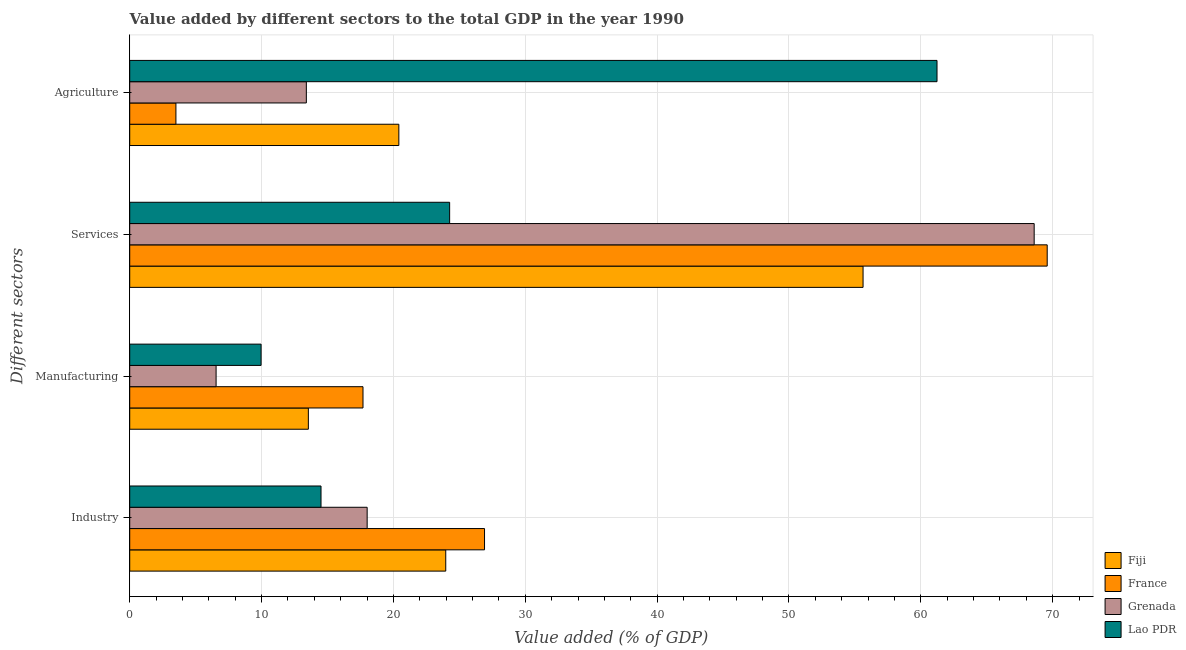Are the number of bars per tick equal to the number of legend labels?
Ensure brevity in your answer.  Yes. Are the number of bars on each tick of the Y-axis equal?
Provide a succinct answer. Yes. How many bars are there on the 3rd tick from the top?
Make the answer very short. 4. How many bars are there on the 3rd tick from the bottom?
Provide a succinct answer. 4. What is the label of the 3rd group of bars from the top?
Offer a very short reply. Manufacturing. What is the value added by industrial sector in Fiji?
Offer a terse response. 23.97. Across all countries, what is the maximum value added by industrial sector?
Keep it short and to the point. 26.91. Across all countries, what is the minimum value added by industrial sector?
Keep it short and to the point. 14.51. In which country was the value added by agricultural sector minimum?
Your answer should be compact. France. What is the total value added by industrial sector in the graph?
Give a very brief answer. 83.4. What is the difference between the value added by agricultural sector in Fiji and that in Grenada?
Your response must be concise. 7.02. What is the difference between the value added by industrial sector in France and the value added by agricultural sector in Lao PDR?
Your response must be concise. -34.32. What is the average value added by industrial sector per country?
Make the answer very short. 20.85. What is the difference between the value added by industrial sector and value added by services sector in Lao PDR?
Give a very brief answer. -9.76. In how many countries, is the value added by agricultural sector greater than 4 %?
Offer a very short reply. 3. What is the ratio of the value added by industrial sector in Fiji to that in Grenada?
Offer a very short reply. 1.33. Is the difference between the value added by services sector in Lao PDR and Grenada greater than the difference between the value added by industrial sector in Lao PDR and Grenada?
Make the answer very short. No. What is the difference between the highest and the second highest value added by agricultural sector?
Offer a terse response. 40.82. What is the difference between the highest and the lowest value added by agricultural sector?
Provide a succinct answer. 57.72. In how many countries, is the value added by agricultural sector greater than the average value added by agricultural sector taken over all countries?
Ensure brevity in your answer.  1. Is the sum of the value added by industrial sector in France and Fiji greater than the maximum value added by manufacturing sector across all countries?
Offer a very short reply. Yes. What does the 2nd bar from the top in Industry represents?
Provide a succinct answer. Grenada. What does the 1st bar from the bottom in Manufacturing represents?
Your answer should be very brief. Fiji. How many bars are there?
Offer a terse response. 16. Are all the bars in the graph horizontal?
Make the answer very short. Yes. How many countries are there in the graph?
Provide a short and direct response. 4. Are the values on the major ticks of X-axis written in scientific E-notation?
Provide a succinct answer. No. Where does the legend appear in the graph?
Keep it short and to the point. Bottom right. How many legend labels are there?
Keep it short and to the point. 4. What is the title of the graph?
Your answer should be very brief. Value added by different sectors to the total GDP in the year 1990. What is the label or title of the X-axis?
Keep it short and to the point. Value added (% of GDP). What is the label or title of the Y-axis?
Offer a very short reply. Different sectors. What is the Value added (% of GDP) in Fiji in Industry?
Offer a terse response. 23.97. What is the Value added (% of GDP) in France in Industry?
Provide a short and direct response. 26.91. What is the Value added (% of GDP) in Grenada in Industry?
Give a very brief answer. 18.01. What is the Value added (% of GDP) in Lao PDR in Industry?
Provide a short and direct response. 14.51. What is the Value added (% of GDP) in Fiji in Manufacturing?
Provide a succinct answer. 13.55. What is the Value added (% of GDP) of France in Manufacturing?
Your answer should be very brief. 17.69. What is the Value added (% of GDP) of Grenada in Manufacturing?
Keep it short and to the point. 6.55. What is the Value added (% of GDP) of Lao PDR in Manufacturing?
Your response must be concise. 9.96. What is the Value added (% of GDP) of Fiji in Services?
Offer a very short reply. 55.62. What is the Value added (% of GDP) of France in Services?
Make the answer very short. 69.59. What is the Value added (% of GDP) of Grenada in Services?
Your answer should be compact. 68.6. What is the Value added (% of GDP) of Lao PDR in Services?
Provide a short and direct response. 24.26. What is the Value added (% of GDP) in Fiji in Agriculture?
Your response must be concise. 20.41. What is the Value added (% of GDP) of France in Agriculture?
Provide a succinct answer. 3.5. What is the Value added (% of GDP) of Grenada in Agriculture?
Provide a succinct answer. 13.4. What is the Value added (% of GDP) in Lao PDR in Agriculture?
Your answer should be compact. 61.23. Across all Different sectors, what is the maximum Value added (% of GDP) in Fiji?
Keep it short and to the point. 55.62. Across all Different sectors, what is the maximum Value added (% of GDP) of France?
Your response must be concise. 69.59. Across all Different sectors, what is the maximum Value added (% of GDP) in Grenada?
Offer a terse response. 68.6. Across all Different sectors, what is the maximum Value added (% of GDP) of Lao PDR?
Make the answer very short. 61.23. Across all Different sectors, what is the minimum Value added (% of GDP) in Fiji?
Offer a terse response. 13.55. Across all Different sectors, what is the minimum Value added (% of GDP) of France?
Offer a terse response. 3.5. Across all Different sectors, what is the minimum Value added (% of GDP) of Grenada?
Offer a terse response. 6.55. Across all Different sectors, what is the minimum Value added (% of GDP) in Lao PDR?
Ensure brevity in your answer.  9.96. What is the total Value added (% of GDP) of Fiji in the graph?
Keep it short and to the point. 113.55. What is the total Value added (% of GDP) in France in the graph?
Give a very brief answer. 117.69. What is the total Value added (% of GDP) in Grenada in the graph?
Offer a terse response. 106.55. What is the total Value added (% of GDP) of Lao PDR in the graph?
Keep it short and to the point. 109.96. What is the difference between the Value added (% of GDP) of Fiji in Industry and that in Manufacturing?
Offer a terse response. 10.42. What is the difference between the Value added (% of GDP) of France in Industry and that in Manufacturing?
Give a very brief answer. 9.22. What is the difference between the Value added (% of GDP) of Grenada in Industry and that in Manufacturing?
Give a very brief answer. 11.46. What is the difference between the Value added (% of GDP) in Lao PDR in Industry and that in Manufacturing?
Offer a very short reply. 4.55. What is the difference between the Value added (% of GDP) in Fiji in Industry and that in Services?
Give a very brief answer. -31.65. What is the difference between the Value added (% of GDP) in France in Industry and that in Services?
Your answer should be compact. -42.67. What is the difference between the Value added (% of GDP) in Grenada in Industry and that in Services?
Offer a very short reply. -50.59. What is the difference between the Value added (% of GDP) of Lao PDR in Industry and that in Services?
Your answer should be very brief. -9.76. What is the difference between the Value added (% of GDP) in Fiji in Industry and that in Agriculture?
Give a very brief answer. 3.56. What is the difference between the Value added (% of GDP) in France in Industry and that in Agriculture?
Make the answer very short. 23.41. What is the difference between the Value added (% of GDP) in Grenada in Industry and that in Agriculture?
Your answer should be very brief. 4.61. What is the difference between the Value added (% of GDP) of Lao PDR in Industry and that in Agriculture?
Provide a short and direct response. -46.72. What is the difference between the Value added (% of GDP) in Fiji in Manufacturing and that in Services?
Make the answer very short. -42.07. What is the difference between the Value added (% of GDP) of France in Manufacturing and that in Services?
Provide a short and direct response. -51.89. What is the difference between the Value added (% of GDP) in Grenada in Manufacturing and that in Services?
Keep it short and to the point. -62.05. What is the difference between the Value added (% of GDP) of Lao PDR in Manufacturing and that in Services?
Provide a succinct answer. -14.3. What is the difference between the Value added (% of GDP) of Fiji in Manufacturing and that in Agriculture?
Give a very brief answer. -6.86. What is the difference between the Value added (% of GDP) in France in Manufacturing and that in Agriculture?
Provide a succinct answer. 14.19. What is the difference between the Value added (% of GDP) in Grenada in Manufacturing and that in Agriculture?
Offer a terse response. -6.84. What is the difference between the Value added (% of GDP) of Lao PDR in Manufacturing and that in Agriculture?
Provide a short and direct response. -51.27. What is the difference between the Value added (% of GDP) of Fiji in Services and that in Agriculture?
Keep it short and to the point. 35.21. What is the difference between the Value added (% of GDP) of France in Services and that in Agriculture?
Your answer should be very brief. 66.08. What is the difference between the Value added (% of GDP) in Grenada in Services and that in Agriculture?
Offer a very short reply. 55.2. What is the difference between the Value added (% of GDP) in Lao PDR in Services and that in Agriculture?
Make the answer very short. -36.96. What is the difference between the Value added (% of GDP) of Fiji in Industry and the Value added (% of GDP) of France in Manufacturing?
Offer a terse response. 6.28. What is the difference between the Value added (% of GDP) of Fiji in Industry and the Value added (% of GDP) of Grenada in Manufacturing?
Keep it short and to the point. 17.42. What is the difference between the Value added (% of GDP) in Fiji in Industry and the Value added (% of GDP) in Lao PDR in Manufacturing?
Provide a short and direct response. 14.01. What is the difference between the Value added (% of GDP) of France in Industry and the Value added (% of GDP) of Grenada in Manufacturing?
Your response must be concise. 20.36. What is the difference between the Value added (% of GDP) in France in Industry and the Value added (% of GDP) in Lao PDR in Manufacturing?
Offer a very short reply. 16.95. What is the difference between the Value added (% of GDP) in Grenada in Industry and the Value added (% of GDP) in Lao PDR in Manufacturing?
Ensure brevity in your answer.  8.04. What is the difference between the Value added (% of GDP) of Fiji in Industry and the Value added (% of GDP) of France in Services?
Your answer should be compact. -45.62. What is the difference between the Value added (% of GDP) of Fiji in Industry and the Value added (% of GDP) of Grenada in Services?
Ensure brevity in your answer.  -44.63. What is the difference between the Value added (% of GDP) in Fiji in Industry and the Value added (% of GDP) in Lao PDR in Services?
Provide a succinct answer. -0.29. What is the difference between the Value added (% of GDP) in France in Industry and the Value added (% of GDP) in Grenada in Services?
Your answer should be very brief. -41.69. What is the difference between the Value added (% of GDP) of France in Industry and the Value added (% of GDP) of Lao PDR in Services?
Make the answer very short. 2.65. What is the difference between the Value added (% of GDP) in Grenada in Industry and the Value added (% of GDP) in Lao PDR in Services?
Ensure brevity in your answer.  -6.26. What is the difference between the Value added (% of GDP) of Fiji in Industry and the Value added (% of GDP) of France in Agriculture?
Ensure brevity in your answer.  20.46. What is the difference between the Value added (% of GDP) in Fiji in Industry and the Value added (% of GDP) in Grenada in Agriculture?
Offer a terse response. 10.57. What is the difference between the Value added (% of GDP) of Fiji in Industry and the Value added (% of GDP) of Lao PDR in Agriculture?
Make the answer very short. -37.26. What is the difference between the Value added (% of GDP) of France in Industry and the Value added (% of GDP) of Grenada in Agriculture?
Ensure brevity in your answer.  13.52. What is the difference between the Value added (% of GDP) of France in Industry and the Value added (% of GDP) of Lao PDR in Agriculture?
Offer a terse response. -34.32. What is the difference between the Value added (% of GDP) of Grenada in Industry and the Value added (% of GDP) of Lao PDR in Agriculture?
Your response must be concise. -43.22. What is the difference between the Value added (% of GDP) of Fiji in Manufacturing and the Value added (% of GDP) of France in Services?
Your answer should be very brief. -56.04. What is the difference between the Value added (% of GDP) of Fiji in Manufacturing and the Value added (% of GDP) of Grenada in Services?
Provide a succinct answer. -55.05. What is the difference between the Value added (% of GDP) of Fiji in Manufacturing and the Value added (% of GDP) of Lao PDR in Services?
Offer a very short reply. -10.72. What is the difference between the Value added (% of GDP) in France in Manufacturing and the Value added (% of GDP) in Grenada in Services?
Give a very brief answer. -50.9. What is the difference between the Value added (% of GDP) of France in Manufacturing and the Value added (% of GDP) of Lao PDR in Services?
Offer a very short reply. -6.57. What is the difference between the Value added (% of GDP) in Grenada in Manufacturing and the Value added (% of GDP) in Lao PDR in Services?
Your answer should be very brief. -17.71. What is the difference between the Value added (% of GDP) in Fiji in Manufacturing and the Value added (% of GDP) in France in Agriculture?
Make the answer very short. 10.04. What is the difference between the Value added (% of GDP) of Fiji in Manufacturing and the Value added (% of GDP) of Grenada in Agriculture?
Keep it short and to the point. 0.15. What is the difference between the Value added (% of GDP) of Fiji in Manufacturing and the Value added (% of GDP) of Lao PDR in Agriculture?
Provide a short and direct response. -47.68. What is the difference between the Value added (% of GDP) in France in Manufacturing and the Value added (% of GDP) in Grenada in Agriculture?
Your answer should be very brief. 4.3. What is the difference between the Value added (% of GDP) in France in Manufacturing and the Value added (% of GDP) in Lao PDR in Agriculture?
Provide a succinct answer. -43.54. What is the difference between the Value added (% of GDP) in Grenada in Manufacturing and the Value added (% of GDP) in Lao PDR in Agriculture?
Keep it short and to the point. -54.68. What is the difference between the Value added (% of GDP) of Fiji in Services and the Value added (% of GDP) of France in Agriculture?
Make the answer very short. 52.12. What is the difference between the Value added (% of GDP) of Fiji in Services and the Value added (% of GDP) of Grenada in Agriculture?
Provide a short and direct response. 42.22. What is the difference between the Value added (% of GDP) of Fiji in Services and the Value added (% of GDP) of Lao PDR in Agriculture?
Provide a succinct answer. -5.61. What is the difference between the Value added (% of GDP) of France in Services and the Value added (% of GDP) of Grenada in Agriculture?
Provide a short and direct response. 56.19. What is the difference between the Value added (% of GDP) in France in Services and the Value added (% of GDP) in Lao PDR in Agriculture?
Your answer should be very brief. 8.36. What is the difference between the Value added (% of GDP) of Grenada in Services and the Value added (% of GDP) of Lao PDR in Agriculture?
Keep it short and to the point. 7.37. What is the average Value added (% of GDP) in Fiji per Different sectors?
Offer a terse response. 28.39. What is the average Value added (% of GDP) in France per Different sectors?
Keep it short and to the point. 29.42. What is the average Value added (% of GDP) in Grenada per Different sectors?
Make the answer very short. 26.64. What is the average Value added (% of GDP) of Lao PDR per Different sectors?
Make the answer very short. 27.49. What is the difference between the Value added (% of GDP) of Fiji and Value added (% of GDP) of France in Industry?
Provide a succinct answer. -2.94. What is the difference between the Value added (% of GDP) of Fiji and Value added (% of GDP) of Grenada in Industry?
Your response must be concise. 5.96. What is the difference between the Value added (% of GDP) in Fiji and Value added (% of GDP) in Lao PDR in Industry?
Make the answer very short. 9.46. What is the difference between the Value added (% of GDP) of France and Value added (% of GDP) of Grenada in Industry?
Your answer should be very brief. 8.9. What is the difference between the Value added (% of GDP) in France and Value added (% of GDP) in Lao PDR in Industry?
Provide a short and direct response. 12.4. What is the difference between the Value added (% of GDP) in Grenada and Value added (% of GDP) in Lao PDR in Industry?
Make the answer very short. 3.5. What is the difference between the Value added (% of GDP) in Fiji and Value added (% of GDP) in France in Manufacturing?
Give a very brief answer. -4.14. What is the difference between the Value added (% of GDP) of Fiji and Value added (% of GDP) of Grenada in Manufacturing?
Ensure brevity in your answer.  7. What is the difference between the Value added (% of GDP) of Fiji and Value added (% of GDP) of Lao PDR in Manufacturing?
Ensure brevity in your answer.  3.58. What is the difference between the Value added (% of GDP) of France and Value added (% of GDP) of Grenada in Manufacturing?
Your answer should be very brief. 11.14. What is the difference between the Value added (% of GDP) in France and Value added (% of GDP) in Lao PDR in Manufacturing?
Offer a very short reply. 7.73. What is the difference between the Value added (% of GDP) in Grenada and Value added (% of GDP) in Lao PDR in Manufacturing?
Your answer should be very brief. -3.41. What is the difference between the Value added (% of GDP) of Fiji and Value added (% of GDP) of France in Services?
Your answer should be very brief. -13.97. What is the difference between the Value added (% of GDP) of Fiji and Value added (% of GDP) of Grenada in Services?
Your answer should be compact. -12.98. What is the difference between the Value added (% of GDP) in Fiji and Value added (% of GDP) in Lao PDR in Services?
Offer a very short reply. 31.36. What is the difference between the Value added (% of GDP) in France and Value added (% of GDP) in Grenada in Services?
Give a very brief answer. 0.99. What is the difference between the Value added (% of GDP) in France and Value added (% of GDP) in Lao PDR in Services?
Your answer should be very brief. 45.32. What is the difference between the Value added (% of GDP) in Grenada and Value added (% of GDP) in Lao PDR in Services?
Provide a short and direct response. 44.33. What is the difference between the Value added (% of GDP) in Fiji and Value added (% of GDP) in France in Agriculture?
Your response must be concise. 16.91. What is the difference between the Value added (% of GDP) of Fiji and Value added (% of GDP) of Grenada in Agriculture?
Your answer should be very brief. 7.02. What is the difference between the Value added (% of GDP) of Fiji and Value added (% of GDP) of Lao PDR in Agriculture?
Ensure brevity in your answer.  -40.82. What is the difference between the Value added (% of GDP) in France and Value added (% of GDP) in Grenada in Agriculture?
Provide a short and direct response. -9.89. What is the difference between the Value added (% of GDP) of France and Value added (% of GDP) of Lao PDR in Agriculture?
Keep it short and to the point. -57.72. What is the difference between the Value added (% of GDP) in Grenada and Value added (% of GDP) in Lao PDR in Agriculture?
Give a very brief answer. -47.83. What is the ratio of the Value added (% of GDP) in Fiji in Industry to that in Manufacturing?
Your response must be concise. 1.77. What is the ratio of the Value added (% of GDP) of France in Industry to that in Manufacturing?
Offer a very short reply. 1.52. What is the ratio of the Value added (% of GDP) of Grenada in Industry to that in Manufacturing?
Your response must be concise. 2.75. What is the ratio of the Value added (% of GDP) in Lao PDR in Industry to that in Manufacturing?
Ensure brevity in your answer.  1.46. What is the ratio of the Value added (% of GDP) of Fiji in Industry to that in Services?
Provide a succinct answer. 0.43. What is the ratio of the Value added (% of GDP) of France in Industry to that in Services?
Provide a short and direct response. 0.39. What is the ratio of the Value added (% of GDP) of Grenada in Industry to that in Services?
Your answer should be very brief. 0.26. What is the ratio of the Value added (% of GDP) in Lao PDR in Industry to that in Services?
Give a very brief answer. 0.6. What is the ratio of the Value added (% of GDP) in Fiji in Industry to that in Agriculture?
Offer a terse response. 1.17. What is the ratio of the Value added (% of GDP) of France in Industry to that in Agriculture?
Your answer should be compact. 7.68. What is the ratio of the Value added (% of GDP) of Grenada in Industry to that in Agriculture?
Offer a very short reply. 1.34. What is the ratio of the Value added (% of GDP) of Lao PDR in Industry to that in Agriculture?
Ensure brevity in your answer.  0.24. What is the ratio of the Value added (% of GDP) of Fiji in Manufacturing to that in Services?
Give a very brief answer. 0.24. What is the ratio of the Value added (% of GDP) in France in Manufacturing to that in Services?
Offer a terse response. 0.25. What is the ratio of the Value added (% of GDP) of Grenada in Manufacturing to that in Services?
Your response must be concise. 0.1. What is the ratio of the Value added (% of GDP) in Lao PDR in Manufacturing to that in Services?
Provide a short and direct response. 0.41. What is the ratio of the Value added (% of GDP) of Fiji in Manufacturing to that in Agriculture?
Offer a terse response. 0.66. What is the ratio of the Value added (% of GDP) in France in Manufacturing to that in Agriculture?
Provide a short and direct response. 5.05. What is the ratio of the Value added (% of GDP) in Grenada in Manufacturing to that in Agriculture?
Make the answer very short. 0.49. What is the ratio of the Value added (% of GDP) in Lao PDR in Manufacturing to that in Agriculture?
Give a very brief answer. 0.16. What is the ratio of the Value added (% of GDP) of Fiji in Services to that in Agriculture?
Provide a short and direct response. 2.72. What is the ratio of the Value added (% of GDP) in France in Services to that in Agriculture?
Keep it short and to the point. 19.86. What is the ratio of the Value added (% of GDP) of Grenada in Services to that in Agriculture?
Make the answer very short. 5.12. What is the ratio of the Value added (% of GDP) in Lao PDR in Services to that in Agriculture?
Make the answer very short. 0.4. What is the difference between the highest and the second highest Value added (% of GDP) of Fiji?
Your answer should be compact. 31.65. What is the difference between the highest and the second highest Value added (% of GDP) in France?
Offer a very short reply. 42.67. What is the difference between the highest and the second highest Value added (% of GDP) of Grenada?
Your answer should be very brief. 50.59. What is the difference between the highest and the second highest Value added (% of GDP) of Lao PDR?
Offer a very short reply. 36.96. What is the difference between the highest and the lowest Value added (% of GDP) of Fiji?
Keep it short and to the point. 42.07. What is the difference between the highest and the lowest Value added (% of GDP) in France?
Offer a very short reply. 66.08. What is the difference between the highest and the lowest Value added (% of GDP) of Grenada?
Offer a terse response. 62.05. What is the difference between the highest and the lowest Value added (% of GDP) in Lao PDR?
Ensure brevity in your answer.  51.27. 